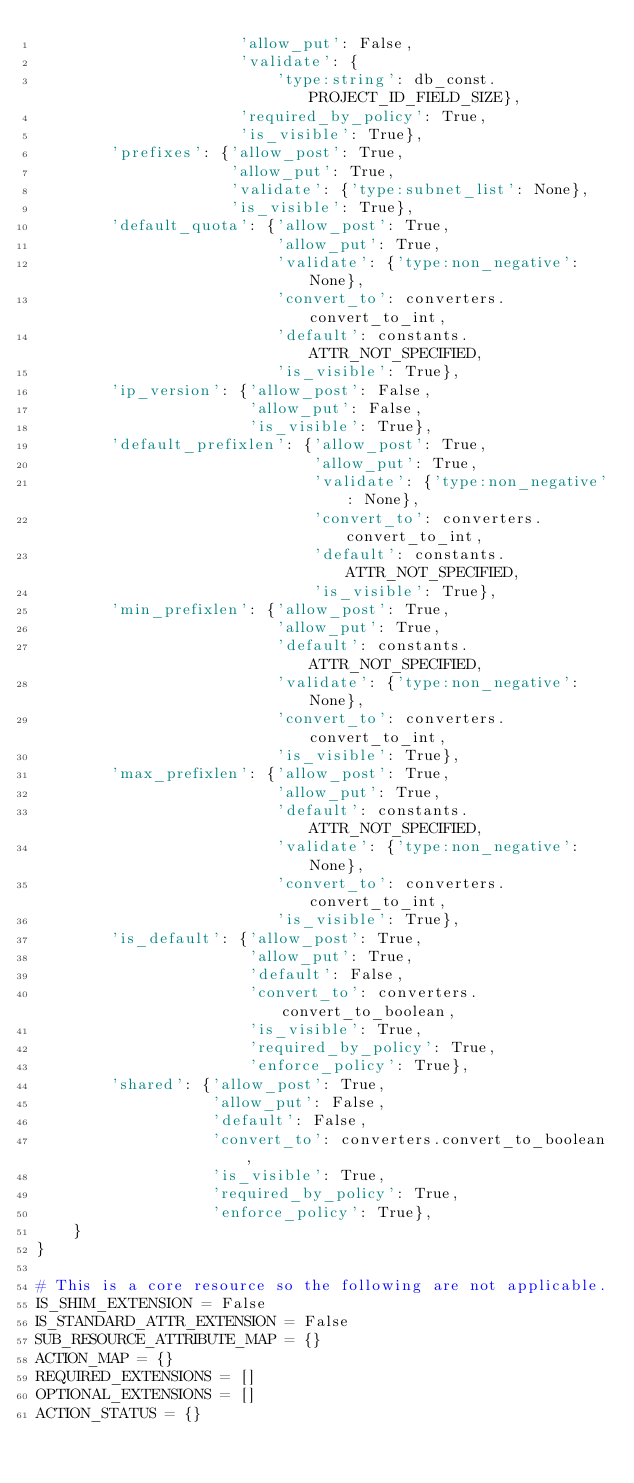<code> <loc_0><loc_0><loc_500><loc_500><_Python_>                      'allow_put': False,
                      'validate': {
                          'type:string': db_const.PROJECT_ID_FIELD_SIZE},
                      'required_by_policy': True,
                      'is_visible': True},
        'prefixes': {'allow_post': True,
                     'allow_put': True,
                     'validate': {'type:subnet_list': None},
                     'is_visible': True},
        'default_quota': {'allow_post': True,
                          'allow_put': True,
                          'validate': {'type:non_negative': None},
                          'convert_to': converters.convert_to_int,
                          'default': constants.ATTR_NOT_SPECIFIED,
                          'is_visible': True},
        'ip_version': {'allow_post': False,
                       'allow_put': False,
                       'is_visible': True},
        'default_prefixlen': {'allow_post': True,
                              'allow_put': True,
                              'validate': {'type:non_negative': None},
                              'convert_to': converters.convert_to_int,
                              'default': constants.ATTR_NOT_SPECIFIED,
                              'is_visible': True},
        'min_prefixlen': {'allow_post': True,
                          'allow_put': True,
                          'default': constants.ATTR_NOT_SPECIFIED,
                          'validate': {'type:non_negative': None},
                          'convert_to': converters.convert_to_int,
                          'is_visible': True},
        'max_prefixlen': {'allow_post': True,
                          'allow_put': True,
                          'default': constants.ATTR_NOT_SPECIFIED,
                          'validate': {'type:non_negative': None},
                          'convert_to': converters.convert_to_int,
                          'is_visible': True},
        'is_default': {'allow_post': True,
                       'allow_put': True,
                       'default': False,
                       'convert_to': converters.convert_to_boolean,
                       'is_visible': True,
                       'required_by_policy': True,
                       'enforce_policy': True},
        'shared': {'allow_post': True,
                   'allow_put': False,
                   'default': False,
                   'convert_to': converters.convert_to_boolean,
                   'is_visible': True,
                   'required_by_policy': True,
                   'enforce_policy': True},
    }
}

# This is a core resource so the following are not applicable.
IS_SHIM_EXTENSION = False
IS_STANDARD_ATTR_EXTENSION = False
SUB_RESOURCE_ATTRIBUTE_MAP = {}
ACTION_MAP = {}
REQUIRED_EXTENSIONS = []
OPTIONAL_EXTENSIONS = []
ACTION_STATUS = {}
</code> 